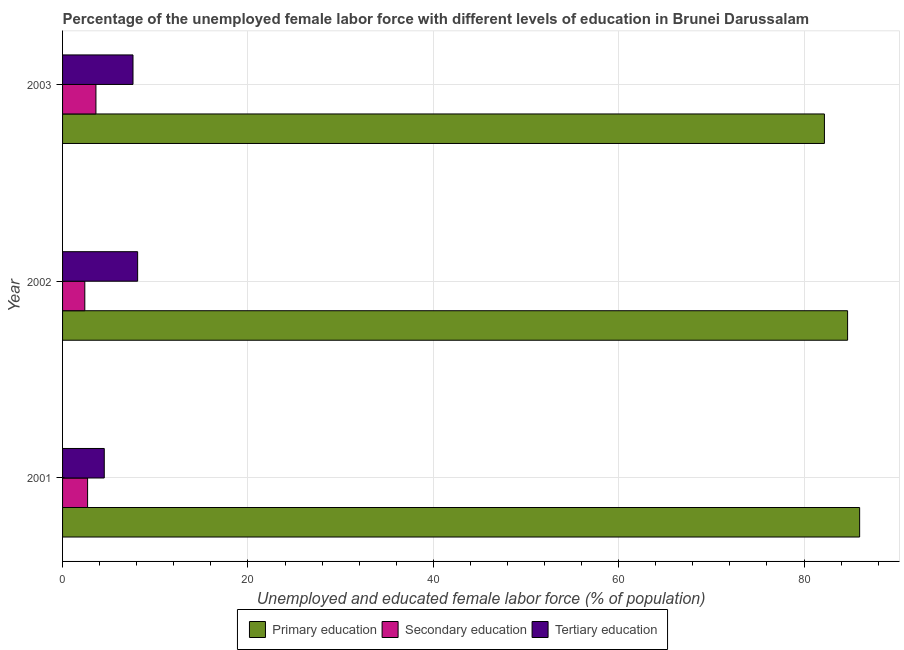How many different coloured bars are there?
Your answer should be very brief. 3. How many groups of bars are there?
Ensure brevity in your answer.  3. In how many cases, is the number of bars for a given year not equal to the number of legend labels?
Keep it short and to the point. 0. What is the percentage of female labor force who received secondary education in 2001?
Offer a very short reply. 2.7. Across all years, what is the maximum percentage of female labor force who received primary education?
Your response must be concise. 86. In which year was the percentage of female labor force who received secondary education maximum?
Keep it short and to the point. 2003. In which year was the percentage of female labor force who received tertiary education minimum?
Give a very brief answer. 2001. What is the total percentage of female labor force who received secondary education in the graph?
Offer a terse response. 8.7. What is the difference between the percentage of female labor force who received tertiary education in 2003 and the percentage of female labor force who received primary education in 2002?
Provide a succinct answer. -77.1. What is the average percentage of female labor force who received tertiary education per year?
Your answer should be compact. 6.73. In the year 2003, what is the difference between the percentage of female labor force who received tertiary education and percentage of female labor force who received primary education?
Keep it short and to the point. -74.6. In how many years, is the percentage of female labor force who received secondary education greater than 8 %?
Provide a short and direct response. 0. What is the ratio of the percentage of female labor force who received secondary education in 2001 to that in 2002?
Your response must be concise. 1.12. Is the percentage of female labor force who received secondary education in 2002 less than that in 2003?
Provide a short and direct response. Yes. Is the difference between the percentage of female labor force who received tertiary education in 2002 and 2003 greater than the difference between the percentage of female labor force who received secondary education in 2002 and 2003?
Ensure brevity in your answer.  Yes. What is the difference between the highest and the second highest percentage of female labor force who received secondary education?
Your answer should be very brief. 0.9. How many years are there in the graph?
Your answer should be very brief. 3. What is the difference between two consecutive major ticks on the X-axis?
Make the answer very short. 20. Does the graph contain any zero values?
Your answer should be compact. No. How many legend labels are there?
Your answer should be compact. 3. What is the title of the graph?
Provide a succinct answer. Percentage of the unemployed female labor force with different levels of education in Brunei Darussalam. Does "Ages 0-14" appear as one of the legend labels in the graph?
Your response must be concise. No. What is the label or title of the X-axis?
Your response must be concise. Unemployed and educated female labor force (% of population). What is the Unemployed and educated female labor force (% of population) in Primary education in 2001?
Give a very brief answer. 86. What is the Unemployed and educated female labor force (% of population) in Secondary education in 2001?
Provide a succinct answer. 2.7. What is the Unemployed and educated female labor force (% of population) of Tertiary education in 2001?
Give a very brief answer. 4.5. What is the Unemployed and educated female labor force (% of population) in Primary education in 2002?
Offer a very short reply. 84.7. What is the Unemployed and educated female labor force (% of population) of Secondary education in 2002?
Your response must be concise. 2.4. What is the Unemployed and educated female labor force (% of population) in Tertiary education in 2002?
Your answer should be very brief. 8.1. What is the Unemployed and educated female labor force (% of population) in Primary education in 2003?
Your answer should be compact. 82.2. What is the Unemployed and educated female labor force (% of population) of Secondary education in 2003?
Provide a short and direct response. 3.6. What is the Unemployed and educated female labor force (% of population) in Tertiary education in 2003?
Keep it short and to the point. 7.6. Across all years, what is the maximum Unemployed and educated female labor force (% of population) in Secondary education?
Ensure brevity in your answer.  3.6. Across all years, what is the maximum Unemployed and educated female labor force (% of population) of Tertiary education?
Make the answer very short. 8.1. Across all years, what is the minimum Unemployed and educated female labor force (% of population) of Primary education?
Ensure brevity in your answer.  82.2. Across all years, what is the minimum Unemployed and educated female labor force (% of population) of Secondary education?
Give a very brief answer. 2.4. What is the total Unemployed and educated female labor force (% of population) of Primary education in the graph?
Make the answer very short. 252.9. What is the total Unemployed and educated female labor force (% of population) in Secondary education in the graph?
Keep it short and to the point. 8.7. What is the total Unemployed and educated female labor force (% of population) in Tertiary education in the graph?
Your response must be concise. 20.2. What is the difference between the Unemployed and educated female labor force (% of population) of Tertiary education in 2001 and that in 2002?
Your answer should be very brief. -3.6. What is the difference between the Unemployed and educated female labor force (% of population) of Primary education in 2001 and that in 2003?
Ensure brevity in your answer.  3.8. What is the difference between the Unemployed and educated female labor force (% of population) of Secondary education in 2002 and that in 2003?
Ensure brevity in your answer.  -1.2. What is the difference between the Unemployed and educated female labor force (% of population) of Tertiary education in 2002 and that in 2003?
Provide a succinct answer. 0.5. What is the difference between the Unemployed and educated female labor force (% of population) in Primary education in 2001 and the Unemployed and educated female labor force (% of population) in Secondary education in 2002?
Your response must be concise. 83.6. What is the difference between the Unemployed and educated female labor force (% of population) in Primary education in 2001 and the Unemployed and educated female labor force (% of population) in Tertiary education in 2002?
Ensure brevity in your answer.  77.9. What is the difference between the Unemployed and educated female labor force (% of population) of Primary education in 2001 and the Unemployed and educated female labor force (% of population) of Secondary education in 2003?
Your response must be concise. 82.4. What is the difference between the Unemployed and educated female labor force (% of population) of Primary education in 2001 and the Unemployed and educated female labor force (% of population) of Tertiary education in 2003?
Your answer should be compact. 78.4. What is the difference between the Unemployed and educated female labor force (% of population) of Primary education in 2002 and the Unemployed and educated female labor force (% of population) of Secondary education in 2003?
Your answer should be very brief. 81.1. What is the difference between the Unemployed and educated female labor force (% of population) of Primary education in 2002 and the Unemployed and educated female labor force (% of population) of Tertiary education in 2003?
Your answer should be compact. 77.1. What is the average Unemployed and educated female labor force (% of population) of Primary education per year?
Give a very brief answer. 84.3. What is the average Unemployed and educated female labor force (% of population) in Tertiary education per year?
Offer a terse response. 6.73. In the year 2001, what is the difference between the Unemployed and educated female labor force (% of population) in Primary education and Unemployed and educated female labor force (% of population) in Secondary education?
Provide a short and direct response. 83.3. In the year 2001, what is the difference between the Unemployed and educated female labor force (% of population) in Primary education and Unemployed and educated female labor force (% of population) in Tertiary education?
Your answer should be compact. 81.5. In the year 2001, what is the difference between the Unemployed and educated female labor force (% of population) of Secondary education and Unemployed and educated female labor force (% of population) of Tertiary education?
Your response must be concise. -1.8. In the year 2002, what is the difference between the Unemployed and educated female labor force (% of population) in Primary education and Unemployed and educated female labor force (% of population) in Secondary education?
Keep it short and to the point. 82.3. In the year 2002, what is the difference between the Unemployed and educated female labor force (% of population) in Primary education and Unemployed and educated female labor force (% of population) in Tertiary education?
Keep it short and to the point. 76.6. In the year 2002, what is the difference between the Unemployed and educated female labor force (% of population) in Secondary education and Unemployed and educated female labor force (% of population) in Tertiary education?
Offer a terse response. -5.7. In the year 2003, what is the difference between the Unemployed and educated female labor force (% of population) in Primary education and Unemployed and educated female labor force (% of population) in Secondary education?
Your answer should be compact. 78.6. In the year 2003, what is the difference between the Unemployed and educated female labor force (% of population) of Primary education and Unemployed and educated female labor force (% of population) of Tertiary education?
Your answer should be very brief. 74.6. What is the ratio of the Unemployed and educated female labor force (% of population) of Primary education in 2001 to that in 2002?
Your answer should be compact. 1.02. What is the ratio of the Unemployed and educated female labor force (% of population) of Secondary education in 2001 to that in 2002?
Provide a succinct answer. 1.12. What is the ratio of the Unemployed and educated female labor force (% of population) in Tertiary education in 2001 to that in 2002?
Make the answer very short. 0.56. What is the ratio of the Unemployed and educated female labor force (% of population) in Primary education in 2001 to that in 2003?
Offer a very short reply. 1.05. What is the ratio of the Unemployed and educated female labor force (% of population) of Secondary education in 2001 to that in 2003?
Ensure brevity in your answer.  0.75. What is the ratio of the Unemployed and educated female labor force (% of population) of Tertiary education in 2001 to that in 2003?
Make the answer very short. 0.59. What is the ratio of the Unemployed and educated female labor force (% of population) of Primary education in 2002 to that in 2003?
Your answer should be compact. 1.03. What is the ratio of the Unemployed and educated female labor force (% of population) in Tertiary education in 2002 to that in 2003?
Your answer should be compact. 1.07. What is the difference between the highest and the second highest Unemployed and educated female labor force (% of population) in Primary education?
Provide a short and direct response. 1.3. What is the difference between the highest and the lowest Unemployed and educated female labor force (% of population) in Secondary education?
Your answer should be very brief. 1.2. 